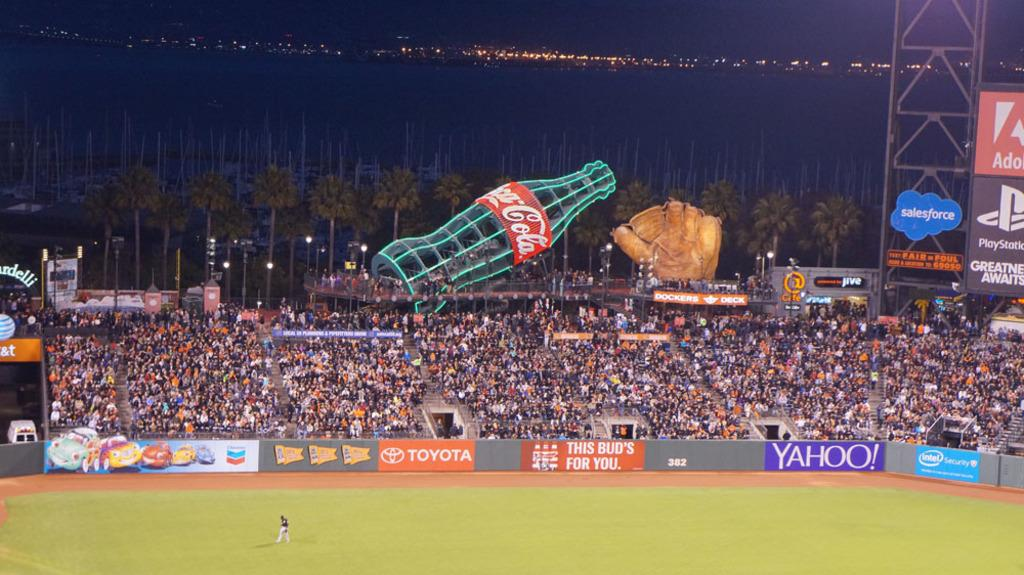<image>
Offer a succinct explanation of the picture presented. Among the sponsors at this baseball stadium are Toyota, Yahoo and Intel. 